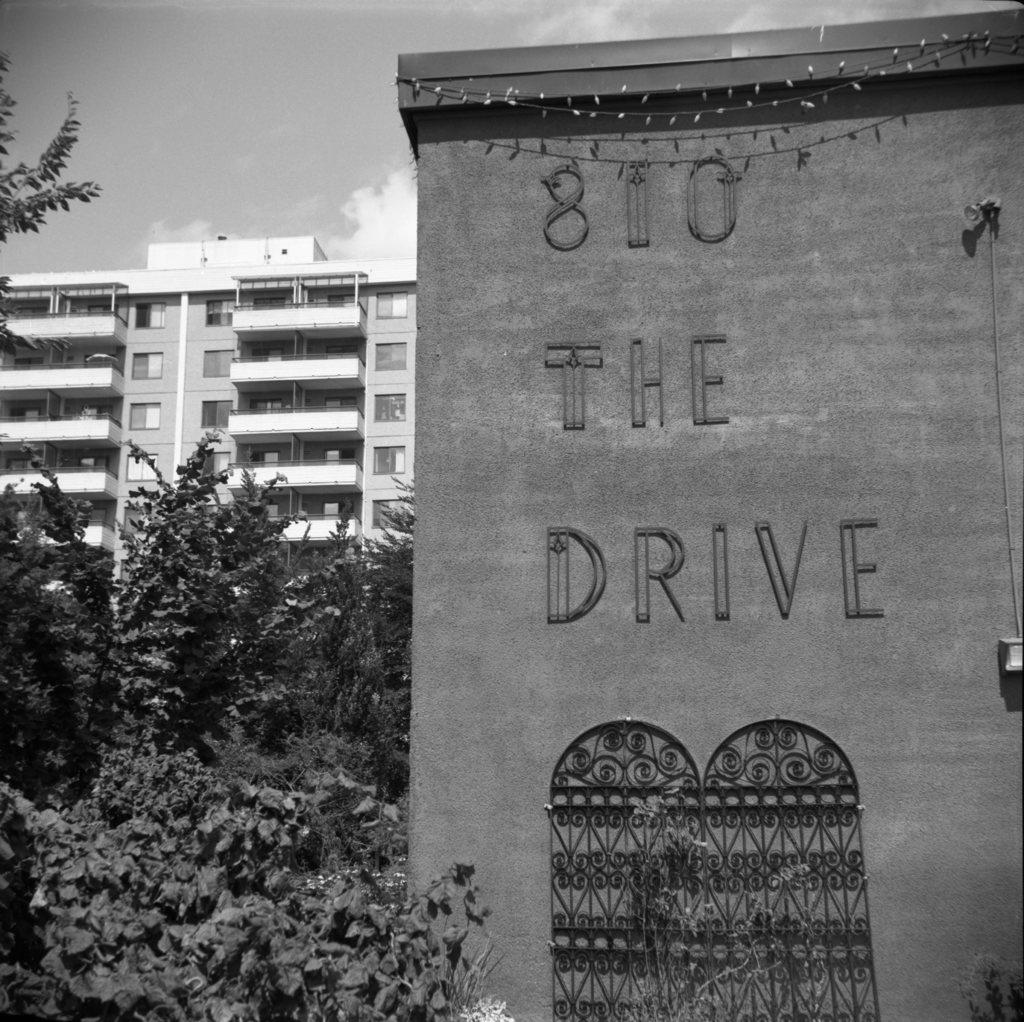What is present on the wall in the image? There is a note on the wall in the image. What can be seen in the background of the image? There are trees and a building in the image. How many goldfish are swimming in the trees in the image? There are no goldfish present in the image; it features a wall with a note, trees, and a building. 